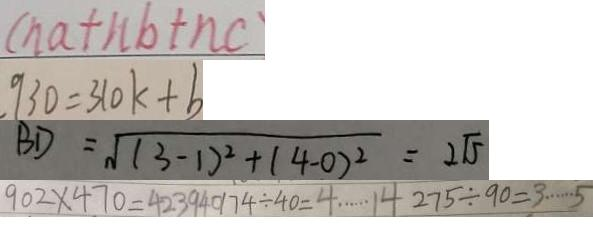Convert formula to latex. <formula><loc_0><loc_0><loc_500><loc_500>( n a + n b + n c ) 
 9 3 0 = 3 1 0 k + b 
 B D = \sqrt { ( 3 - 1 ) ^ { 2 } + ( 4 - 0 ) ^ { 2 } } = 2 \sqrt { 5 } 
 9 0 2 \times 4 7 0 = 4 2 3 9 4 0 1 7 4 \div 4 0 = 4 \cdots 1 4 2 7 5 \div 9 0 = 3 \cdots 5</formula> 